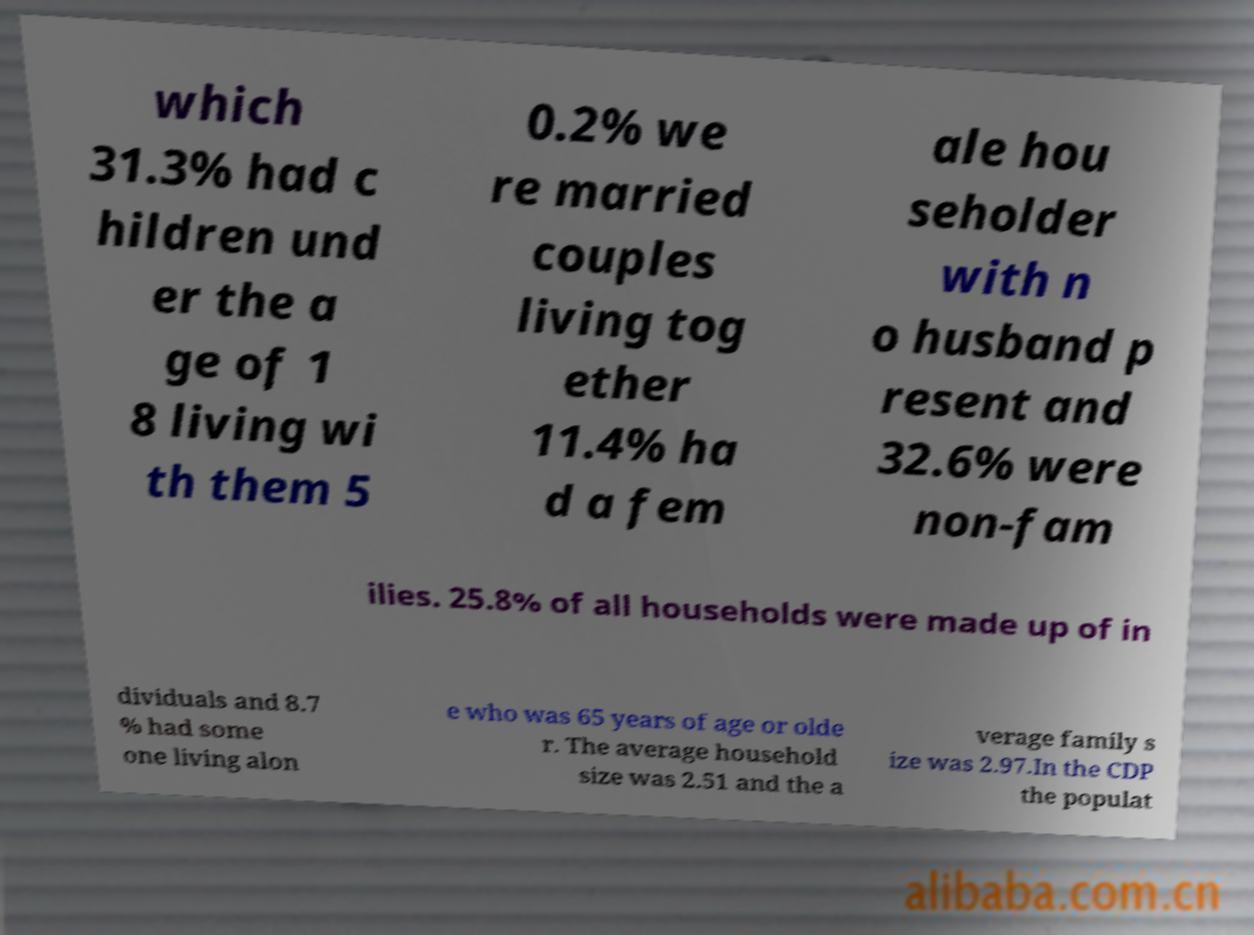I need the written content from this picture converted into text. Can you do that? which 31.3% had c hildren und er the a ge of 1 8 living wi th them 5 0.2% we re married couples living tog ether 11.4% ha d a fem ale hou seholder with n o husband p resent and 32.6% were non-fam ilies. 25.8% of all households were made up of in dividuals and 8.7 % had some one living alon e who was 65 years of age or olde r. The average household size was 2.51 and the a verage family s ize was 2.97.In the CDP the populat 